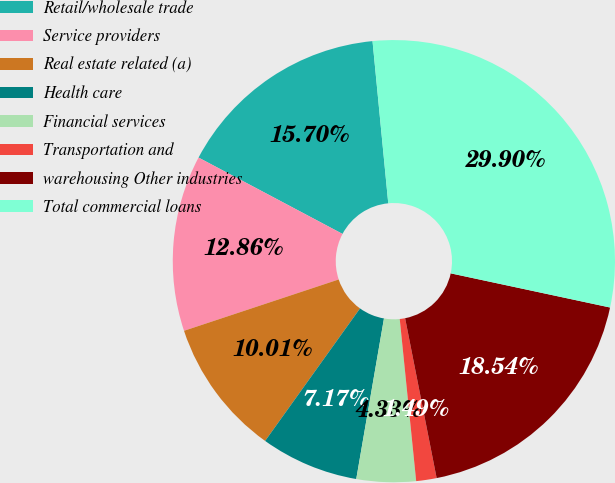<chart> <loc_0><loc_0><loc_500><loc_500><pie_chart><fcel>Retail/wholesale trade<fcel>Service providers<fcel>Real estate related (a)<fcel>Health care<fcel>Financial services<fcel>Transportation and<fcel>warehousing Other industries<fcel>Total commercial loans<nl><fcel>15.7%<fcel>12.86%<fcel>10.01%<fcel>7.17%<fcel>4.33%<fcel>1.49%<fcel>18.54%<fcel>29.9%<nl></chart> 